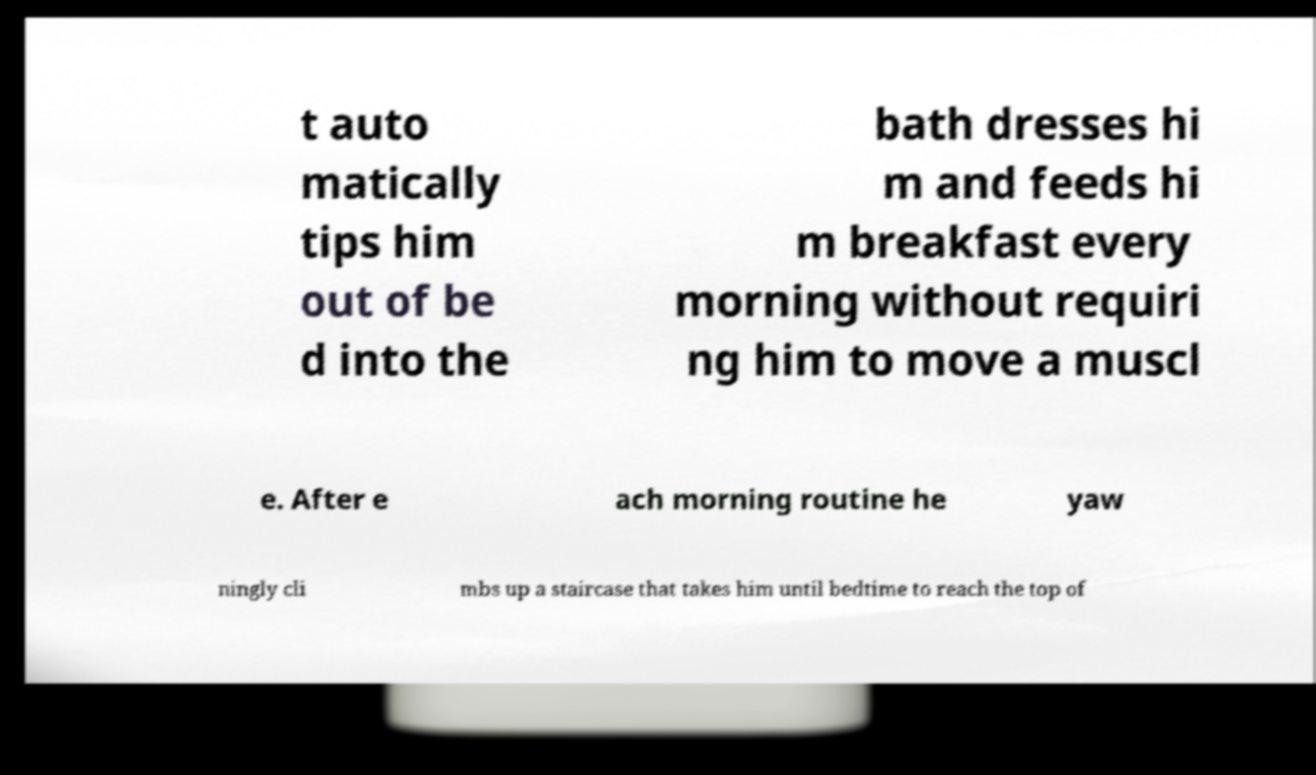There's text embedded in this image that I need extracted. Can you transcribe it verbatim? t auto matically tips him out of be d into the bath dresses hi m and feeds hi m breakfast every morning without requiri ng him to move a muscl e. After e ach morning routine he yaw ningly cli mbs up a staircase that takes him until bedtime to reach the top of 